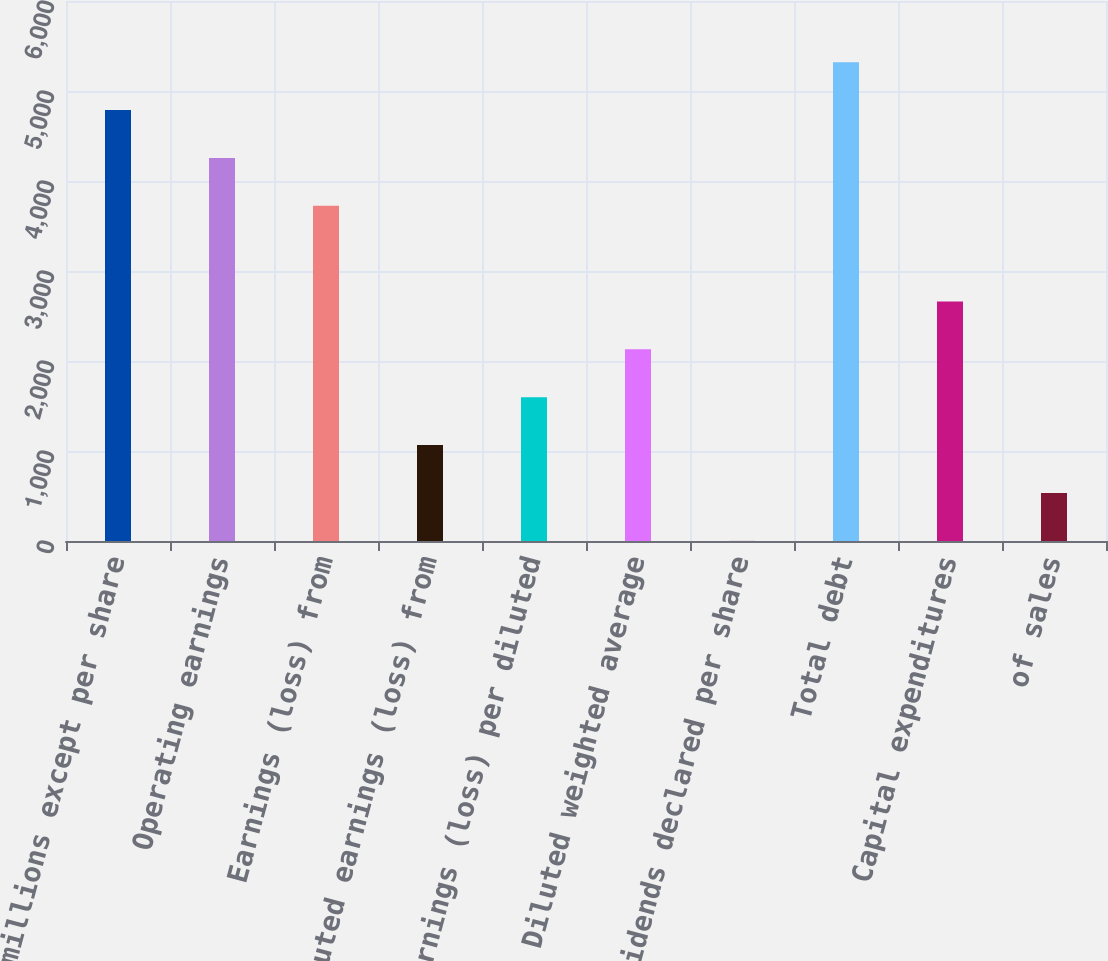Convert chart to OTSL. <chart><loc_0><loc_0><loc_500><loc_500><bar_chart><fcel>(In millions except per share<fcel>Operating earnings<fcel>Earnings (loss) from<fcel>Diluted earnings (loss) from<fcel>Earnings (loss) per diluted<fcel>Diluted weighted average<fcel>Dividends declared per share<fcel>Total debt<fcel>Capital expenditures<fcel>of sales<nl><fcel>4788.24<fcel>4256.45<fcel>3724.66<fcel>1065.71<fcel>1597.5<fcel>2129.29<fcel>2.13<fcel>5320.03<fcel>2661.08<fcel>533.92<nl></chart> 